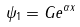Convert formula to latex. <formula><loc_0><loc_0><loc_500><loc_500>\psi _ { 1 } = G e ^ { \alpha x } \,</formula> 